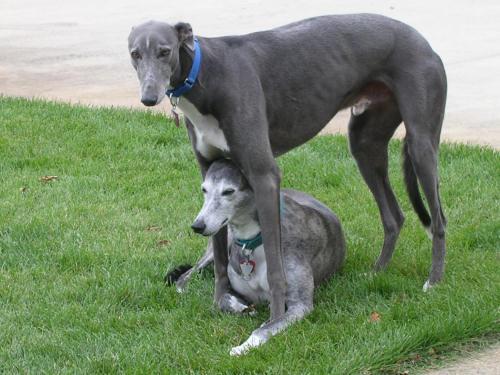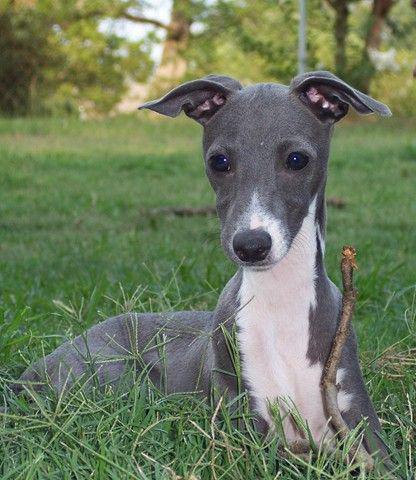The first image is the image on the left, the second image is the image on the right. Analyze the images presented: Is the assertion "At least one of the dogs in the image on the left is standing on all four legs." valid? Answer yes or no. Yes. The first image is the image on the left, the second image is the image on the right. Examine the images to the left and right. Is the description "A hound wears a turtle-neck wrap in one image, and the other image shows a hound wearing a dog collar." accurate? Answer yes or no. No. 